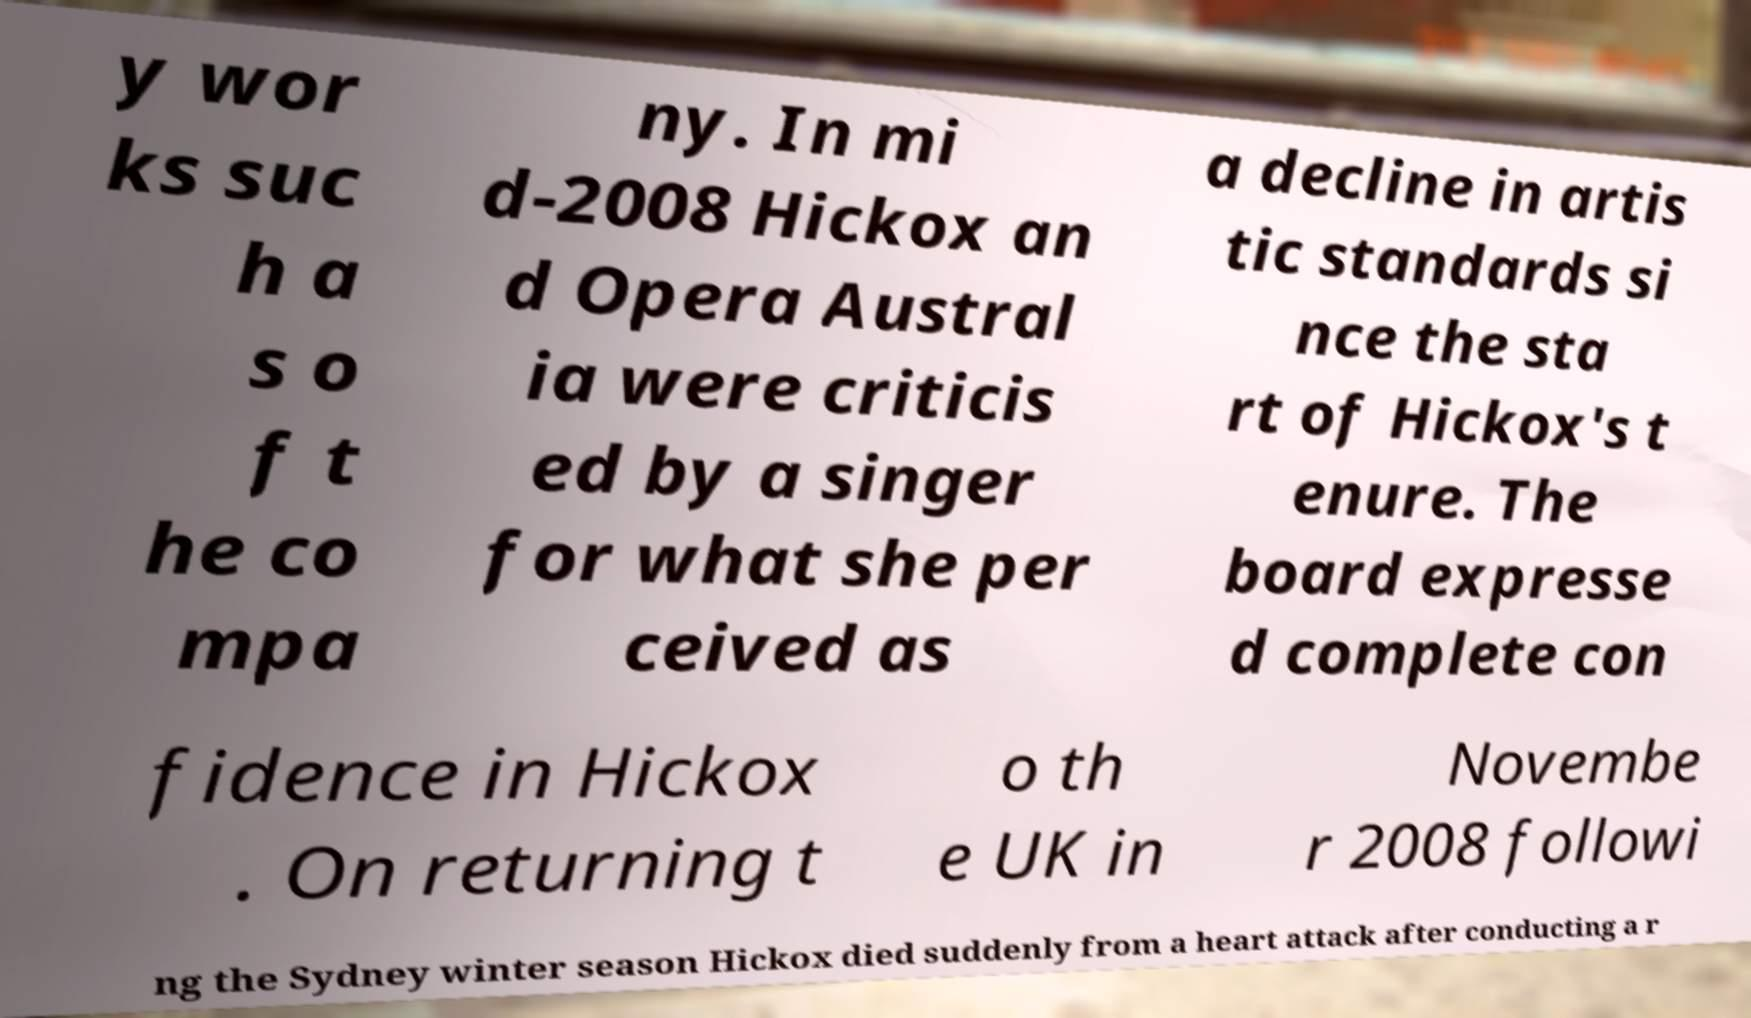Can you accurately transcribe the text from the provided image for me? y wor ks suc h a s o f t he co mpa ny. In mi d-2008 Hickox an d Opera Austral ia were criticis ed by a singer for what she per ceived as a decline in artis tic standards si nce the sta rt of Hickox's t enure. The board expresse d complete con fidence in Hickox . On returning t o th e UK in Novembe r 2008 followi ng the Sydney winter season Hickox died suddenly from a heart attack after conducting a r 